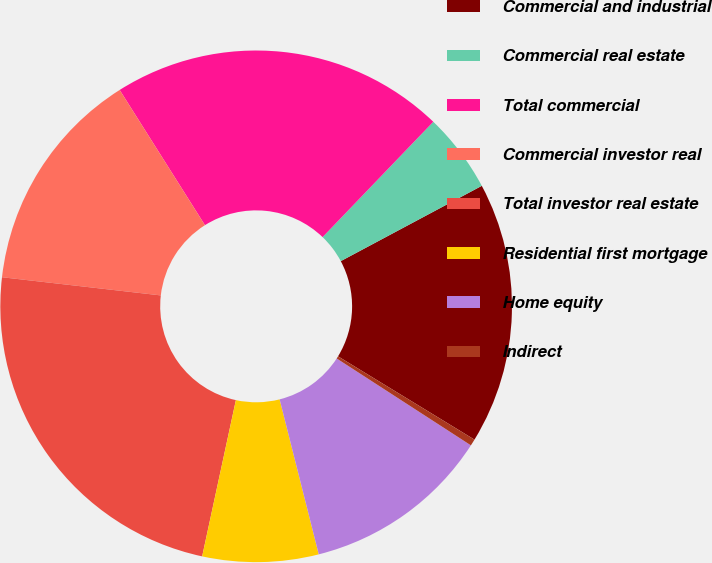<chart> <loc_0><loc_0><loc_500><loc_500><pie_chart><fcel>Commercial and industrial<fcel>Commercial real estate<fcel>Total commercial<fcel>Commercial investor real<fcel>Total investor real estate<fcel>Residential first mortgage<fcel>Home equity<fcel>Indirect<nl><fcel>16.53%<fcel>5.02%<fcel>21.13%<fcel>14.23%<fcel>23.43%<fcel>7.32%<fcel>11.92%<fcel>0.42%<nl></chart> 